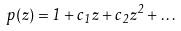<formula> <loc_0><loc_0><loc_500><loc_500>p ( z ) = 1 + c _ { 1 } z + c _ { 2 } z ^ { 2 } + \dots \,</formula> 